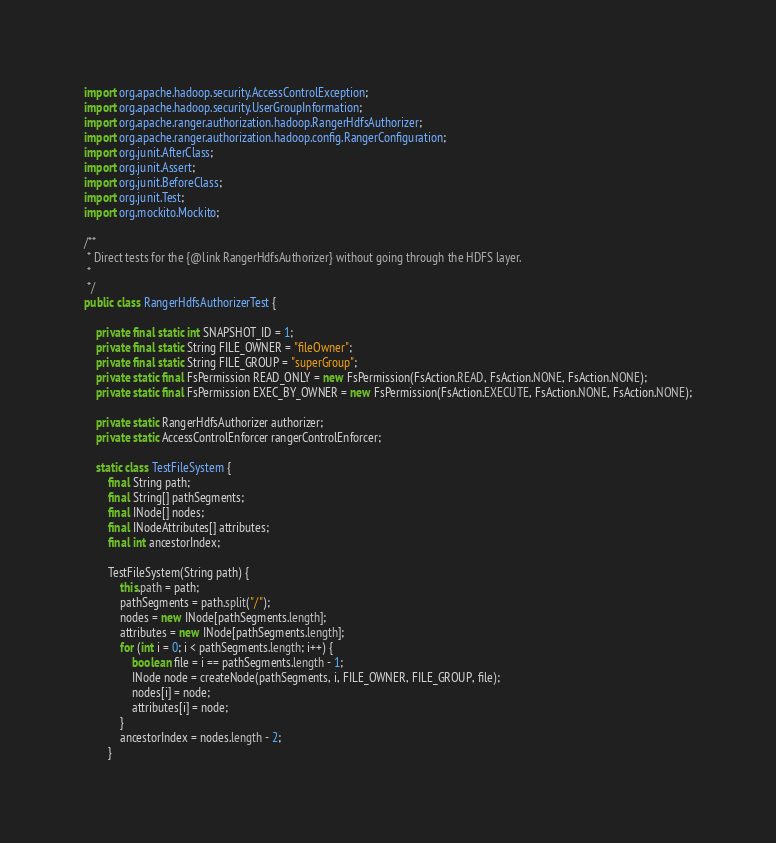<code> <loc_0><loc_0><loc_500><loc_500><_Java_>import org.apache.hadoop.security.AccessControlException;
import org.apache.hadoop.security.UserGroupInformation;
import org.apache.ranger.authorization.hadoop.RangerHdfsAuthorizer;
import org.apache.ranger.authorization.hadoop.config.RangerConfiguration;
import org.junit.AfterClass;
import org.junit.Assert;
import org.junit.BeforeClass;
import org.junit.Test;
import org.mockito.Mockito;

/**
 * Direct tests for the {@link RangerHdfsAuthorizer} without going through the HDFS layer.
 *
 */
public class RangerHdfsAuthorizerTest {

    private final static int SNAPSHOT_ID = 1;
    private final static String FILE_OWNER = "fileOwner";
    private final static String FILE_GROUP = "superGroup";
    private static final FsPermission READ_ONLY = new FsPermission(FsAction.READ, FsAction.NONE, FsAction.NONE);
    private static final FsPermission EXEC_BY_OWNER = new FsPermission(FsAction.EXECUTE, FsAction.NONE, FsAction.NONE);

    private static RangerHdfsAuthorizer authorizer;
    private static AccessControlEnforcer rangerControlEnforcer;

    static class TestFileSystem {
        final String path;
        final String[] pathSegments;
        final INode[] nodes;
        final INodeAttributes[] attributes;
        final int ancestorIndex;

        TestFileSystem(String path) {
            this.path = path;
            pathSegments = path.split("/");
            nodes = new INode[pathSegments.length];
            attributes = new INode[pathSegments.length];
            for (int i = 0; i < pathSegments.length; i++) {
                boolean file = i == pathSegments.length - 1;
                INode node = createNode(pathSegments, i, FILE_OWNER, FILE_GROUP, file);
                nodes[i] = node;
                attributes[i] = node;
            }
            ancestorIndex = nodes.length - 2;
        }
</code> 